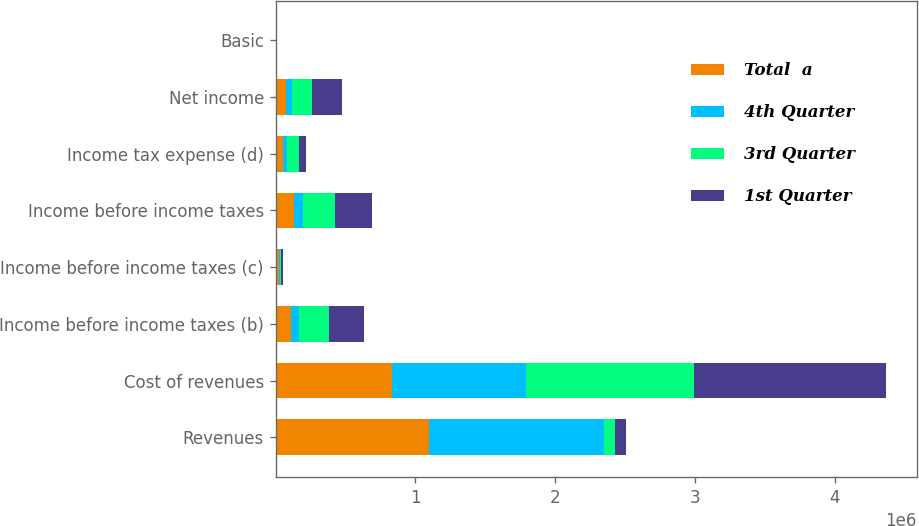<chart> <loc_0><loc_0><loc_500><loc_500><stacked_bar_chart><ecel><fcel>Revenues<fcel>Cost of revenues<fcel>Income before income taxes (b)<fcel>Income before income taxes (c)<fcel>Income before income taxes<fcel>Income tax expense (d)<fcel>Net income<fcel>Basic<nl><fcel>Total  a<fcel>1.094e+06<fcel>833614<fcel>108435<fcel>21594<fcel>130029<fcel>55210<fcel>74819<fcel>0.19<nl><fcel>4th Quarter<fcel>1.25499e+06<fcel>959524<fcel>58573<fcel>9108<fcel>67681<fcel>25801<fcel>41880<fcel>0.11<nl><fcel>3rd Quarter<fcel>79601<fcel>1.19891e+06<fcel>214051<fcel>10877<fcel>224928<fcel>84383<fcel>140545<fcel>0.37<nl><fcel>1st Quarter<fcel>79601<fcel>1.37495e+06<fcel>254118<fcel>13002<fcel>267120<fcel>50025<fcel>217095<fcel>0.58<nl></chart> 